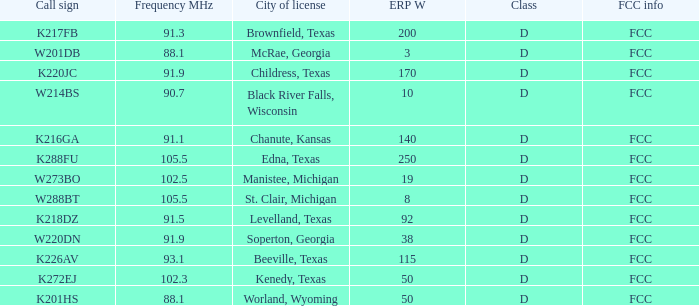Could you parse the entire table as a dict? {'header': ['Call sign', 'Frequency MHz', 'City of license', 'ERP W', 'Class', 'FCC info'], 'rows': [['K217FB', '91.3', 'Brownfield, Texas', '200', 'D', 'FCC'], ['W201DB', '88.1', 'McRae, Georgia', '3', 'D', 'FCC'], ['K220JC', '91.9', 'Childress, Texas', '170', 'D', 'FCC'], ['W214BS', '90.7', 'Black River Falls, Wisconsin', '10', 'D', 'FCC'], ['K216GA', '91.1', 'Chanute, Kansas', '140', 'D', 'FCC'], ['K288FU', '105.5', 'Edna, Texas', '250', 'D', 'FCC'], ['W273BO', '102.5', 'Manistee, Michigan', '19', 'D', 'FCC'], ['W288BT', '105.5', 'St. Clair, Michigan', '8', 'D', 'FCC'], ['K218DZ', '91.5', 'Levelland, Texas', '92', 'D', 'FCC'], ['W220DN', '91.9', 'Soperton, Georgia', '38', 'D', 'FCC'], ['K226AV', '93.1', 'Beeville, Texas', '115', 'D', 'FCC'], ['K272EJ', '102.3', 'Kenedy, Texas', '50', 'D', 'FCC'], ['K201HS', '88.1', 'Worland, Wyoming', '50', 'D', 'FCC']]} What is Call Sign, when ERP W is greater than 50? K216GA, K226AV, K217FB, K220JC, K288FU, K218DZ. 